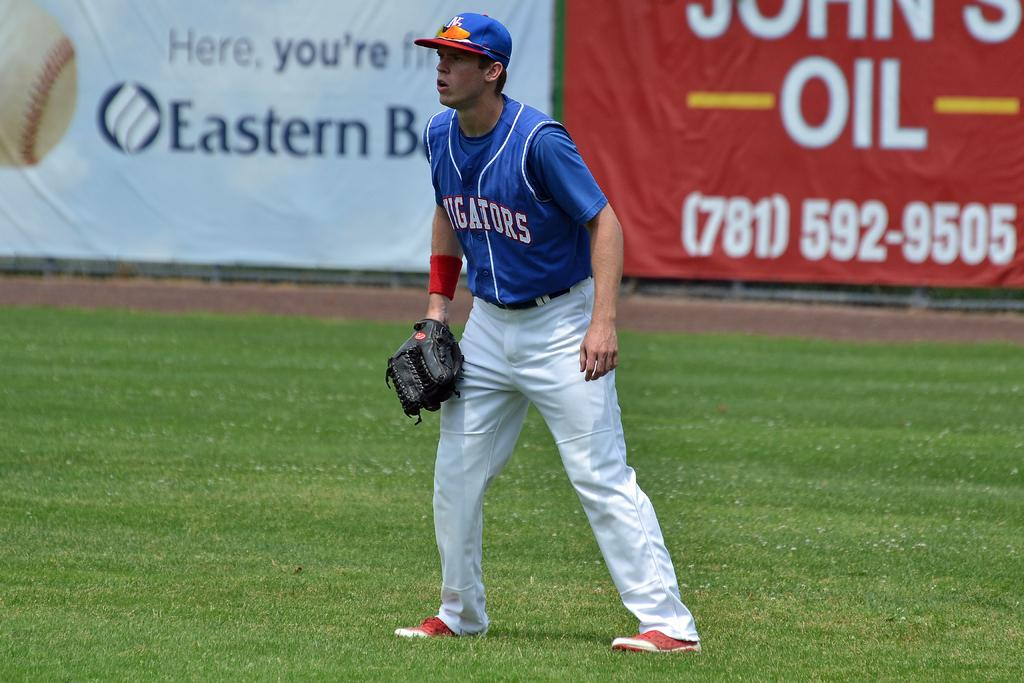<image>
Describe the image concisely. A baseball game with a banner advertising the phone number (781)592-9505 behind a player. 